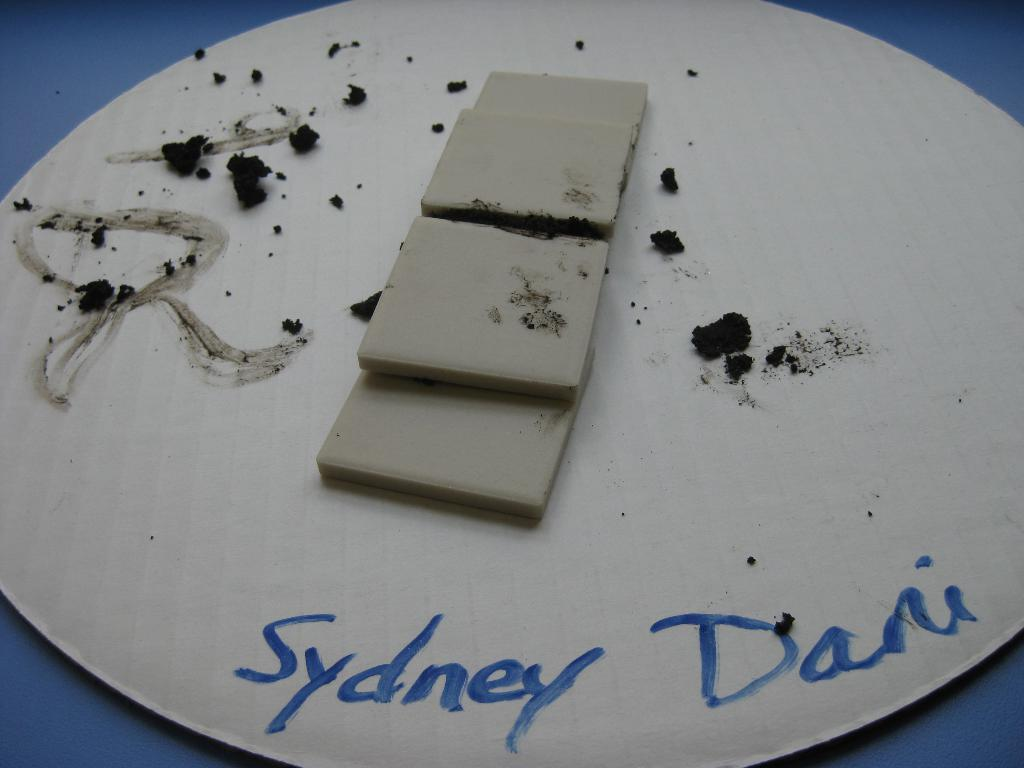What is present on the plate in the image? There are objects placed on the plate in the image. Can you describe the objects on the plate? Unfortunately, the facts provided do not specify the objects on the plate, so we cannot describe them. What is written at the bottom of the image? There is text written at the bottom of the image. What type of poison is being used to destroy the education system in the image? There is no mention of poison, destruction, or education in the image, so this question cannot be answered. 